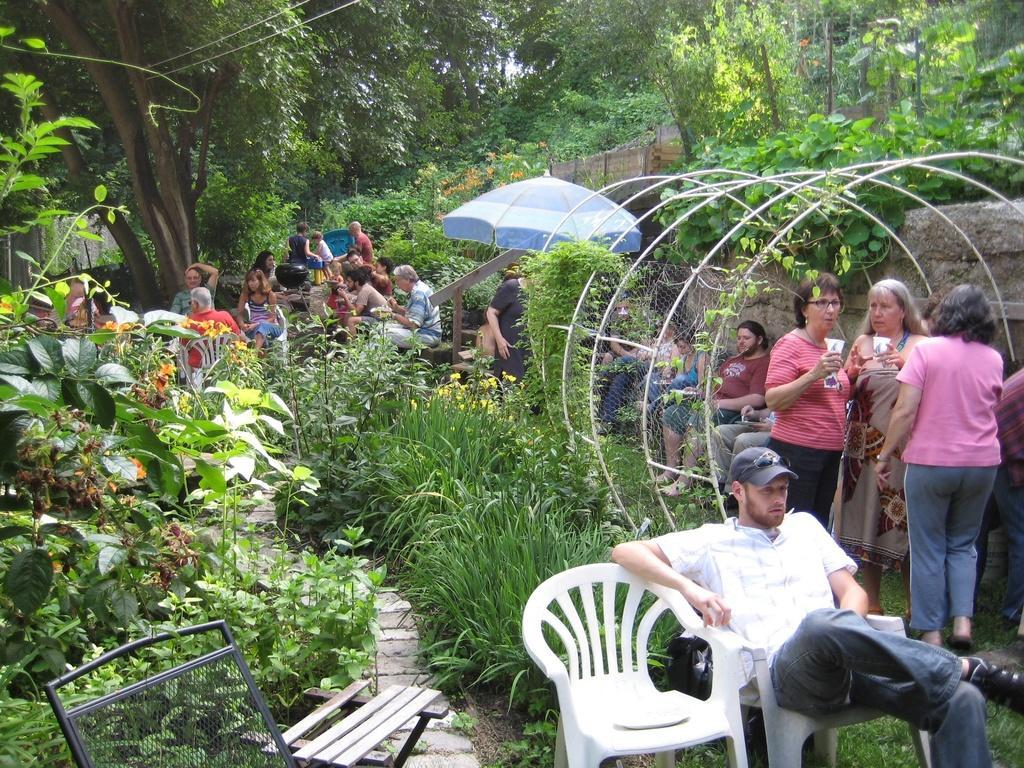Please provide a concise description of this image. In this image I see number of people, in which few of them are sitting and rest of them are standing. I can also see there are lots of plants and trees. 